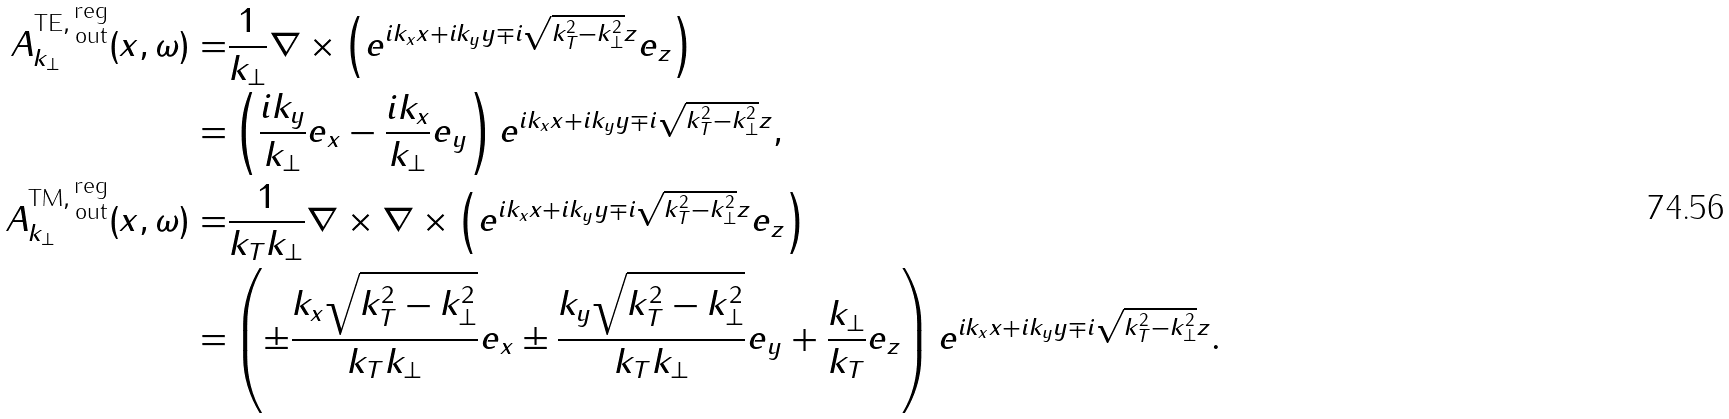<formula> <loc_0><loc_0><loc_500><loc_500>A ^ { \text {TE} , \, \substack { \text {reg} \\ \text {out} } } _ { k _ { \perp } } ( x , \omega ) = & \frac { 1 } { k _ { \perp } } \nabla \times \left ( e ^ { i k _ { x } x + i k _ { y } y \mp i \sqrt { k _ { T } ^ { 2 } - k _ { \perp } ^ { 2 } } z } e _ { z } \right ) \\ = & \left ( \frac { i k _ { y } } { k _ { \perp } } e _ { x } - \frac { i k _ { x } } { k _ { \perp } } e _ { y } \right ) e ^ { i k _ { x } x + i k _ { y } y \mp i \sqrt { k _ { T } ^ { 2 } - k _ { \perp } ^ { 2 } } z } , \\ A ^ { \text {TM} , \, \substack { \text {reg} \\ \text {out} } } _ { k _ { \perp } } ( x , \omega ) = & \frac { 1 } { k _ { T } k _ { \perp } } \nabla \times \nabla \times \left ( e ^ { i k _ { x } x + i k _ { y } y \mp i \sqrt { k _ { T } ^ { 2 } - k _ { \perp } ^ { 2 } } z } e _ { z } \right ) \\ = & \left ( \pm \frac { k _ { x } \sqrt { k _ { T } ^ { 2 } - k _ { \perp } ^ { 2 } } } { k _ { T } k _ { \perp } } e _ { x } \pm \frac { k _ { y } \sqrt { k _ { T } ^ { 2 } - k _ { \perp } ^ { 2 } } } { k _ { T } k _ { \perp } } e _ { y } + \frac { k _ { \perp } } { k _ { T } } e _ { z } \right ) e ^ { i k _ { x } x + i k _ { y } y \mp i \sqrt { k _ { T } ^ { 2 } - k _ { \perp } ^ { 2 } } z } .</formula> 